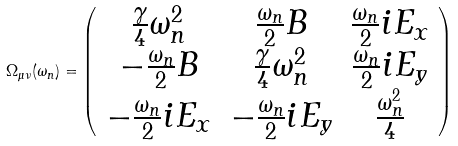<formula> <loc_0><loc_0><loc_500><loc_500>\Omega _ { \mu \nu } ( \omega _ { n } ) = \left ( \begin{array} { c c c } \frac { \gamma } { 4 } \omega _ { n } ^ { 2 } & \frac { \omega _ { n } } { 2 } B & \frac { \omega _ { n } } { 2 } i E _ { x } \\ - \frac { \omega _ { n } } { 2 } B & \frac { \gamma } { 4 } \omega _ { n } ^ { 2 } & \frac { \omega _ { n } } { 2 } i E _ { y } \\ - \frac { \omega _ { n } } { 2 } i E _ { x } & - \frac { \omega _ { n } } { 2 } i E _ { y } & \frac { \omega _ { n } ^ { 2 } } { 4 } \\ \end{array} \right )</formula> 